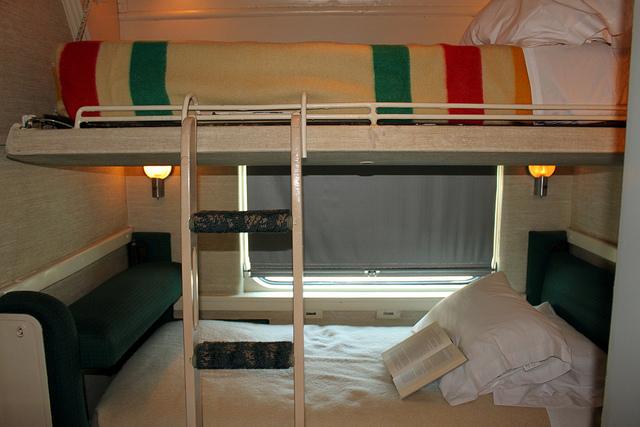What shape is at the bottom of the pole?
Keep it brief. Rectangle. Are both beds made?
Write a very short answer. Yes. Is there a ladder in the picture?
Keep it brief. Yes. How many steps does it take to get to the top?
Keep it brief. 2. What type of bed is in the picture?
Be succinct. Bunk bed. 